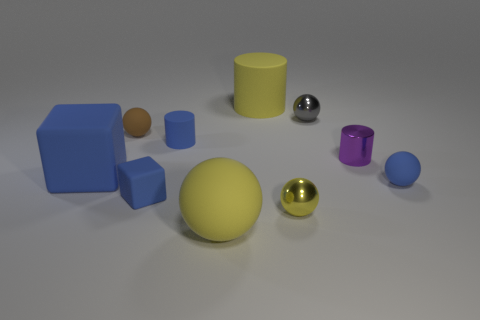There is a big cube that is made of the same material as the small block; what is its color?
Give a very brief answer. Blue. Are there any objects of the same size as the brown ball?
Offer a very short reply. Yes. Do the tiny metal sphere to the left of the tiny gray thing and the big matte block have the same color?
Make the answer very short. No. There is a thing that is left of the yellow shiny object and behind the brown ball; what color is it?
Keep it short and to the point. Yellow. The blue rubber thing that is the same size as the yellow matte sphere is what shape?
Your response must be concise. Cube. Is there another object of the same shape as the small purple shiny object?
Your answer should be compact. Yes. There is a rubber sphere that is on the right side of the gray object; is its size the same as the big blue block?
Keep it short and to the point. No. There is a blue rubber object that is to the left of the small blue cylinder and in front of the large cube; how big is it?
Offer a terse response. Small. How many other objects are the same material as the big cylinder?
Provide a succinct answer. 6. There is a yellow rubber thing behind the tiny brown matte thing; what is its size?
Your answer should be very brief. Large. 